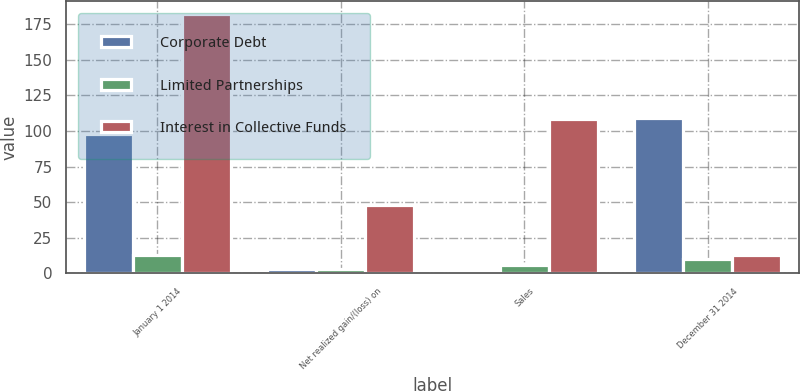<chart> <loc_0><loc_0><loc_500><loc_500><stacked_bar_chart><ecel><fcel>January 1 2014<fcel>Net realized gain/(loss) on<fcel>Sales<fcel>December 31 2014<nl><fcel>Corporate Debt<fcel>98<fcel>3<fcel>1<fcel>109<nl><fcel>Limited Partnerships<fcel>13<fcel>3<fcel>6<fcel>10<nl><fcel>Interest in Collective Funds<fcel>182<fcel>48<fcel>108<fcel>13<nl></chart> 